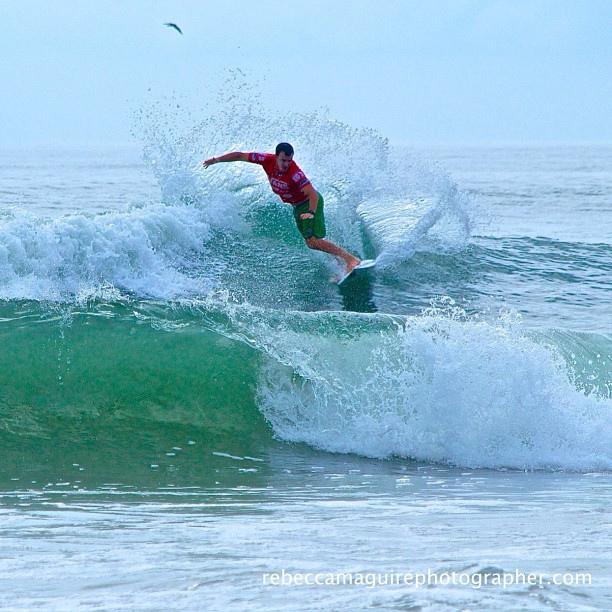Is he surfing?
Keep it brief. Yes. Is this an awesome photo?
Keep it brief. Yes. Is the surfer wearing a wetsuit?
Give a very brief answer. No. 